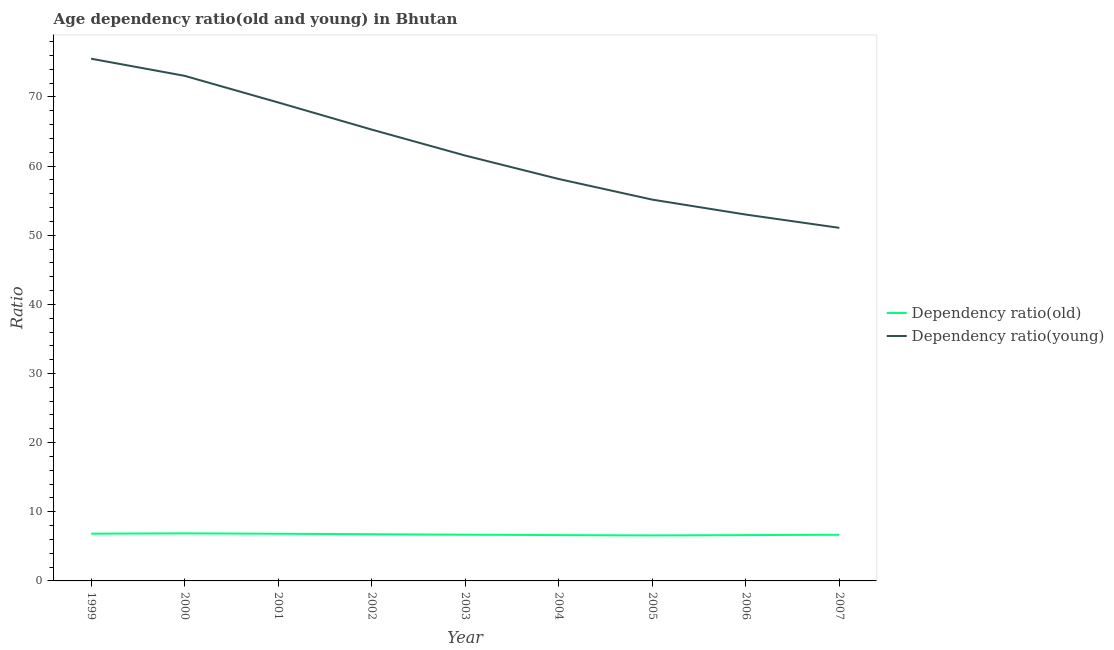How many different coloured lines are there?
Make the answer very short. 2. Does the line corresponding to age dependency ratio(young) intersect with the line corresponding to age dependency ratio(old)?
Make the answer very short. No. What is the age dependency ratio(old) in 2004?
Your answer should be very brief. 6.63. Across all years, what is the maximum age dependency ratio(young)?
Offer a very short reply. 75.53. Across all years, what is the minimum age dependency ratio(old)?
Provide a succinct answer. 6.58. In which year was the age dependency ratio(old) minimum?
Offer a terse response. 2005. What is the total age dependency ratio(young) in the graph?
Your answer should be very brief. 561.95. What is the difference between the age dependency ratio(young) in 2003 and that in 2005?
Your answer should be very brief. 6.37. What is the difference between the age dependency ratio(young) in 1999 and the age dependency ratio(old) in 2001?
Give a very brief answer. 68.71. What is the average age dependency ratio(old) per year?
Provide a succinct answer. 6.72. In the year 1999, what is the difference between the age dependency ratio(old) and age dependency ratio(young)?
Offer a terse response. -68.7. What is the ratio of the age dependency ratio(old) in 2001 to that in 2005?
Provide a short and direct response. 1.04. What is the difference between the highest and the second highest age dependency ratio(old)?
Ensure brevity in your answer.  0.05. What is the difference between the highest and the lowest age dependency ratio(old)?
Your answer should be compact. 0.3. How many legend labels are there?
Your answer should be compact. 2. What is the title of the graph?
Your answer should be compact. Age dependency ratio(old and young) in Bhutan. What is the label or title of the Y-axis?
Your answer should be compact. Ratio. What is the Ratio in Dependency ratio(old) in 1999?
Offer a terse response. 6.83. What is the Ratio in Dependency ratio(young) in 1999?
Keep it short and to the point. 75.53. What is the Ratio in Dependency ratio(old) in 2000?
Offer a terse response. 6.88. What is the Ratio in Dependency ratio(young) in 2000?
Ensure brevity in your answer.  73.06. What is the Ratio in Dependency ratio(old) in 2001?
Offer a very short reply. 6.82. What is the Ratio in Dependency ratio(young) in 2001?
Your response must be concise. 69.21. What is the Ratio of Dependency ratio(old) in 2002?
Your answer should be very brief. 6.75. What is the Ratio of Dependency ratio(young) in 2002?
Your answer should be compact. 65.28. What is the Ratio of Dependency ratio(old) in 2003?
Your answer should be compact. 6.69. What is the Ratio of Dependency ratio(young) in 2003?
Your answer should be compact. 61.53. What is the Ratio of Dependency ratio(old) in 2004?
Offer a very short reply. 6.63. What is the Ratio in Dependency ratio(young) in 2004?
Provide a short and direct response. 58.14. What is the Ratio of Dependency ratio(old) in 2005?
Your answer should be compact. 6.58. What is the Ratio in Dependency ratio(young) in 2005?
Provide a short and direct response. 55.15. What is the Ratio of Dependency ratio(old) in 2006?
Your response must be concise. 6.63. What is the Ratio in Dependency ratio(young) in 2006?
Offer a very short reply. 52.99. What is the Ratio of Dependency ratio(old) in 2007?
Your answer should be compact. 6.68. What is the Ratio of Dependency ratio(young) in 2007?
Make the answer very short. 51.07. Across all years, what is the maximum Ratio in Dependency ratio(old)?
Offer a very short reply. 6.88. Across all years, what is the maximum Ratio in Dependency ratio(young)?
Provide a short and direct response. 75.53. Across all years, what is the minimum Ratio of Dependency ratio(old)?
Offer a very short reply. 6.58. Across all years, what is the minimum Ratio in Dependency ratio(young)?
Keep it short and to the point. 51.07. What is the total Ratio of Dependency ratio(old) in the graph?
Your answer should be compact. 60.49. What is the total Ratio of Dependency ratio(young) in the graph?
Your answer should be very brief. 561.95. What is the difference between the Ratio of Dependency ratio(old) in 1999 and that in 2000?
Offer a terse response. -0.05. What is the difference between the Ratio in Dependency ratio(young) in 1999 and that in 2000?
Provide a succinct answer. 2.48. What is the difference between the Ratio of Dependency ratio(old) in 1999 and that in 2001?
Offer a very short reply. 0.01. What is the difference between the Ratio in Dependency ratio(young) in 1999 and that in 2001?
Make the answer very short. 6.33. What is the difference between the Ratio of Dependency ratio(old) in 1999 and that in 2002?
Give a very brief answer. 0.08. What is the difference between the Ratio of Dependency ratio(young) in 1999 and that in 2002?
Offer a very short reply. 10.25. What is the difference between the Ratio of Dependency ratio(old) in 1999 and that in 2003?
Keep it short and to the point. 0.15. What is the difference between the Ratio in Dependency ratio(young) in 1999 and that in 2003?
Keep it short and to the point. 14.01. What is the difference between the Ratio of Dependency ratio(old) in 1999 and that in 2004?
Your answer should be compact. 0.2. What is the difference between the Ratio in Dependency ratio(young) in 1999 and that in 2004?
Your answer should be compact. 17.4. What is the difference between the Ratio of Dependency ratio(old) in 1999 and that in 2005?
Provide a short and direct response. 0.25. What is the difference between the Ratio in Dependency ratio(young) in 1999 and that in 2005?
Offer a terse response. 20.38. What is the difference between the Ratio in Dependency ratio(old) in 1999 and that in 2006?
Keep it short and to the point. 0.2. What is the difference between the Ratio in Dependency ratio(young) in 1999 and that in 2006?
Keep it short and to the point. 22.54. What is the difference between the Ratio in Dependency ratio(old) in 1999 and that in 2007?
Keep it short and to the point. 0.16. What is the difference between the Ratio of Dependency ratio(young) in 1999 and that in 2007?
Your answer should be very brief. 24.46. What is the difference between the Ratio of Dependency ratio(old) in 2000 and that in 2001?
Your answer should be very brief. 0.06. What is the difference between the Ratio in Dependency ratio(young) in 2000 and that in 2001?
Offer a very short reply. 3.85. What is the difference between the Ratio in Dependency ratio(old) in 2000 and that in 2002?
Your answer should be very brief. 0.13. What is the difference between the Ratio of Dependency ratio(young) in 2000 and that in 2002?
Offer a terse response. 7.78. What is the difference between the Ratio in Dependency ratio(old) in 2000 and that in 2003?
Provide a succinct answer. 0.19. What is the difference between the Ratio in Dependency ratio(young) in 2000 and that in 2003?
Make the answer very short. 11.53. What is the difference between the Ratio of Dependency ratio(old) in 2000 and that in 2004?
Provide a succinct answer. 0.25. What is the difference between the Ratio in Dependency ratio(young) in 2000 and that in 2004?
Give a very brief answer. 14.92. What is the difference between the Ratio of Dependency ratio(old) in 2000 and that in 2005?
Provide a short and direct response. 0.3. What is the difference between the Ratio in Dependency ratio(young) in 2000 and that in 2005?
Give a very brief answer. 17.91. What is the difference between the Ratio of Dependency ratio(old) in 2000 and that in 2006?
Provide a succinct answer. 0.25. What is the difference between the Ratio in Dependency ratio(young) in 2000 and that in 2006?
Provide a short and direct response. 20.07. What is the difference between the Ratio in Dependency ratio(old) in 2000 and that in 2007?
Your answer should be very brief. 0.2. What is the difference between the Ratio of Dependency ratio(young) in 2000 and that in 2007?
Ensure brevity in your answer.  21.99. What is the difference between the Ratio in Dependency ratio(old) in 2001 and that in 2002?
Your answer should be very brief. 0.07. What is the difference between the Ratio in Dependency ratio(young) in 2001 and that in 2002?
Ensure brevity in your answer.  3.93. What is the difference between the Ratio of Dependency ratio(old) in 2001 and that in 2003?
Keep it short and to the point. 0.14. What is the difference between the Ratio in Dependency ratio(young) in 2001 and that in 2003?
Your response must be concise. 7.68. What is the difference between the Ratio in Dependency ratio(old) in 2001 and that in 2004?
Offer a very short reply. 0.19. What is the difference between the Ratio of Dependency ratio(young) in 2001 and that in 2004?
Your answer should be very brief. 11.07. What is the difference between the Ratio of Dependency ratio(old) in 2001 and that in 2005?
Give a very brief answer. 0.24. What is the difference between the Ratio of Dependency ratio(young) in 2001 and that in 2005?
Your response must be concise. 14.06. What is the difference between the Ratio in Dependency ratio(old) in 2001 and that in 2006?
Keep it short and to the point. 0.19. What is the difference between the Ratio of Dependency ratio(young) in 2001 and that in 2006?
Offer a very short reply. 16.22. What is the difference between the Ratio of Dependency ratio(old) in 2001 and that in 2007?
Give a very brief answer. 0.15. What is the difference between the Ratio of Dependency ratio(young) in 2001 and that in 2007?
Your answer should be compact. 18.14. What is the difference between the Ratio in Dependency ratio(old) in 2002 and that in 2003?
Keep it short and to the point. 0.07. What is the difference between the Ratio of Dependency ratio(young) in 2002 and that in 2003?
Keep it short and to the point. 3.76. What is the difference between the Ratio of Dependency ratio(old) in 2002 and that in 2004?
Ensure brevity in your answer.  0.13. What is the difference between the Ratio in Dependency ratio(young) in 2002 and that in 2004?
Your response must be concise. 7.15. What is the difference between the Ratio in Dependency ratio(old) in 2002 and that in 2005?
Make the answer very short. 0.17. What is the difference between the Ratio in Dependency ratio(young) in 2002 and that in 2005?
Your answer should be compact. 10.13. What is the difference between the Ratio in Dependency ratio(old) in 2002 and that in 2006?
Offer a terse response. 0.12. What is the difference between the Ratio in Dependency ratio(young) in 2002 and that in 2006?
Offer a terse response. 12.29. What is the difference between the Ratio in Dependency ratio(old) in 2002 and that in 2007?
Offer a very short reply. 0.08. What is the difference between the Ratio of Dependency ratio(young) in 2002 and that in 2007?
Provide a short and direct response. 14.21. What is the difference between the Ratio in Dependency ratio(old) in 2003 and that in 2004?
Give a very brief answer. 0.06. What is the difference between the Ratio of Dependency ratio(young) in 2003 and that in 2004?
Your answer should be compact. 3.39. What is the difference between the Ratio of Dependency ratio(old) in 2003 and that in 2005?
Offer a very short reply. 0.1. What is the difference between the Ratio in Dependency ratio(young) in 2003 and that in 2005?
Offer a terse response. 6.37. What is the difference between the Ratio in Dependency ratio(old) in 2003 and that in 2006?
Your answer should be very brief. 0.06. What is the difference between the Ratio in Dependency ratio(young) in 2003 and that in 2006?
Provide a succinct answer. 8.53. What is the difference between the Ratio in Dependency ratio(old) in 2003 and that in 2007?
Offer a terse response. 0.01. What is the difference between the Ratio of Dependency ratio(young) in 2003 and that in 2007?
Provide a short and direct response. 10.46. What is the difference between the Ratio in Dependency ratio(old) in 2004 and that in 2005?
Your answer should be very brief. 0.05. What is the difference between the Ratio of Dependency ratio(young) in 2004 and that in 2005?
Offer a terse response. 2.98. What is the difference between the Ratio of Dependency ratio(old) in 2004 and that in 2006?
Ensure brevity in your answer.  -0. What is the difference between the Ratio of Dependency ratio(young) in 2004 and that in 2006?
Provide a succinct answer. 5.14. What is the difference between the Ratio in Dependency ratio(old) in 2004 and that in 2007?
Offer a very short reply. -0.05. What is the difference between the Ratio in Dependency ratio(young) in 2004 and that in 2007?
Ensure brevity in your answer.  7.07. What is the difference between the Ratio in Dependency ratio(old) in 2005 and that in 2006?
Your response must be concise. -0.05. What is the difference between the Ratio in Dependency ratio(young) in 2005 and that in 2006?
Provide a short and direct response. 2.16. What is the difference between the Ratio of Dependency ratio(old) in 2005 and that in 2007?
Your answer should be compact. -0.09. What is the difference between the Ratio of Dependency ratio(young) in 2005 and that in 2007?
Your answer should be very brief. 4.08. What is the difference between the Ratio of Dependency ratio(old) in 2006 and that in 2007?
Offer a very short reply. -0.05. What is the difference between the Ratio of Dependency ratio(young) in 2006 and that in 2007?
Your response must be concise. 1.92. What is the difference between the Ratio in Dependency ratio(old) in 1999 and the Ratio in Dependency ratio(young) in 2000?
Your answer should be compact. -66.22. What is the difference between the Ratio in Dependency ratio(old) in 1999 and the Ratio in Dependency ratio(young) in 2001?
Make the answer very short. -62.37. What is the difference between the Ratio of Dependency ratio(old) in 1999 and the Ratio of Dependency ratio(young) in 2002?
Your answer should be very brief. -58.45. What is the difference between the Ratio of Dependency ratio(old) in 1999 and the Ratio of Dependency ratio(young) in 2003?
Provide a succinct answer. -54.69. What is the difference between the Ratio in Dependency ratio(old) in 1999 and the Ratio in Dependency ratio(young) in 2004?
Keep it short and to the point. -51.3. What is the difference between the Ratio in Dependency ratio(old) in 1999 and the Ratio in Dependency ratio(young) in 2005?
Offer a terse response. -48.32. What is the difference between the Ratio in Dependency ratio(old) in 1999 and the Ratio in Dependency ratio(young) in 2006?
Your response must be concise. -46.16. What is the difference between the Ratio in Dependency ratio(old) in 1999 and the Ratio in Dependency ratio(young) in 2007?
Make the answer very short. -44.24. What is the difference between the Ratio in Dependency ratio(old) in 2000 and the Ratio in Dependency ratio(young) in 2001?
Your answer should be very brief. -62.33. What is the difference between the Ratio of Dependency ratio(old) in 2000 and the Ratio of Dependency ratio(young) in 2002?
Give a very brief answer. -58.4. What is the difference between the Ratio in Dependency ratio(old) in 2000 and the Ratio in Dependency ratio(young) in 2003?
Offer a terse response. -54.64. What is the difference between the Ratio of Dependency ratio(old) in 2000 and the Ratio of Dependency ratio(young) in 2004?
Ensure brevity in your answer.  -51.26. What is the difference between the Ratio in Dependency ratio(old) in 2000 and the Ratio in Dependency ratio(young) in 2005?
Your answer should be very brief. -48.27. What is the difference between the Ratio of Dependency ratio(old) in 2000 and the Ratio of Dependency ratio(young) in 2006?
Your answer should be compact. -46.11. What is the difference between the Ratio of Dependency ratio(old) in 2000 and the Ratio of Dependency ratio(young) in 2007?
Provide a short and direct response. -44.19. What is the difference between the Ratio in Dependency ratio(old) in 2001 and the Ratio in Dependency ratio(young) in 2002?
Give a very brief answer. -58.46. What is the difference between the Ratio of Dependency ratio(old) in 2001 and the Ratio of Dependency ratio(young) in 2003?
Provide a short and direct response. -54.7. What is the difference between the Ratio in Dependency ratio(old) in 2001 and the Ratio in Dependency ratio(young) in 2004?
Give a very brief answer. -51.31. What is the difference between the Ratio of Dependency ratio(old) in 2001 and the Ratio of Dependency ratio(young) in 2005?
Ensure brevity in your answer.  -48.33. What is the difference between the Ratio in Dependency ratio(old) in 2001 and the Ratio in Dependency ratio(young) in 2006?
Offer a very short reply. -46.17. What is the difference between the Ratio of Dependency ratio(old) in 2001 and the Ratio of Dependency ratio(young) in 2007?
Offer a very short reply. -44.25. What is the difference between the Ratio of Dependency ratio(old) in 2002 and the Ratio of Dependency ratio(young) in 2003?
Give a very brief answer. -54.77. What is the difference between the Ratio in Dependency ratio(old) in 2002 and the Ratio in Dependency ratio(young) in 2004?
Your response must be concise. -51.38. What is the difference between the Ratio of Dependency ratio(old) in 2002 and the Ratio of Dependency ratio(young) in 2005?
Your response must be concise. -48.4. What is the difference between the Ratio in Dependency ratio(old) in 2002 and the Ratio in Dependency ratio(young) in 2006?
Offer a very short reply. -46.24. What is the difference between the Ratio in Dependency ratio(old) in 2002 and the Ratio in Dependency ratio(young) in 2007?
Give a very brief answer. -44.32. What is the difference between the Ratio in Dependency ratio(old) in 2003 and the Ratio in Dependency ratio(young) in 2004?
Ensure brevity in your answer.  -51.45. What is the difference between the Ratio in Dependency ratio(old) in 2003 and the Ratio in Dependency ratio(young) in 2005?
Offer a terse response. -48.46. What is the difference between the Ratio in Dependency ratio(old) in 2003 and the Ratio in Dependency ratio(young) in 2006?
Offer a very short reply. -46.3. What is the difference between the Ratio in Dependency ratio(old) in 2003 and the Ratio in Dependency ratio(young) in 2007?
Provide a short and direct response. -44.38. What is the difference between the Ratio in Dependency ratio(old) in 2004 and the Ratio in Dependency ratio(young) in 2005?
Offer a very short reply. -48.52. What is the difference between the Ratio of Dependency ratio(old) in 2004 and the Ratio of Dependency ratio(young) in 2006?
Your response must be concise. -46.36. What is the difference between the Ratio of Dependency ratio(old) in 2004 and the Ratio of Dependency ratio(young) in 2007?
Give a very brief answer. -44.44. What is the difference between the Ratio in Dependency ratio(old) in 2005 and the Ratio in Dependency ratio(young) in 2006?
Offer a very short reply. -46.41. What is the difference between the Ratio of Dependency ratio(old) in 2005 and the Ratio of Dependency ratio(young) in 2007?
Keep it short and to the point. -44.49. What is the difference between the Ratio in Dependency ratio(old) in 2006 and the Ratio in Dependency ratio(young) in 2007?
Your answer should be compact. -44.44. What is the average Ratio of Dependency ratio(old) per year?
Make the answer very short. 6.72. What is the average Ratio in Dependency ratio(young) per year?
Provide a succinct answer. 62.44. In the year 1999, what is the difference between the Ratio in Dependency ratio(old) and Ratio in Dependency ratio(young)?
Offer a terse response. -68.7. In the year 2000, what is the difference between the Ratio of Dependency ratio(old) and Ratio of Dependency ratio(young)?
Your answer should be compact. -66.18. In the year 2001, what is the difference between the Ratio in Dependency ratio(old) and Ratio in Dependency ratio(young)?
Your answer should be compact. -62.38. In the year 2002, what is the difference between the Ratio of Dependency ratio(old) and Ratio of Dependency ratio(young)?
Your answer should be very brief. -58.53. In the year 2003, what is the difference between the Ratio of Dependency ratio(old) and Ratio of Dependency ratio(young)?
Provide a succinct answer. -54.84. In the year 2004, what is the difference between the Ratio in Dependency ratio(old) and Ratio in Dependency ratio(young)?
Ensure brevity in your answer.  -51.51. In the year 2005, what is the difference between the Ratio of Dependency ratio(old) and Ratio of Dependency ratio(young)?
Give a very brief answer. -48.57. In the year 2006, what is the difference between the Ratio of Dependency ratio(old) and Ratio of Dependency ratio(young)?
Give a very brief answer. -46.36. In the year 2007, what is the difference between the Ratio in Dependency ratio(old) and Ratio in Dependency ratio(young)?
Your answer should be compact. -44.39. What is the ratio of the Ratio of Dependency ratio(old) in 1999 to that in 2000?
Your answer should be compact. 0.99. What is the ratio of the Ratio of Dependency ratio(young) in 1999 to that in 2000?
Offer a very short reply. 1.03. What is the ratio of the Ratio in Dependency ratio(young) in 1999 to that in 2001?
Your answer should be very brief. 1.09. What is the ratio of the Ratio in Dependency ratio(old) in 1999 to that in 2002?
Your response must be concise. 1.01. What is the ratio of the Ratio in Dependency ratio(young) in 1999 to that in 2002?
Provide a short and direct response. 1.16. What is the ratio of the Ratio in Dependency ratio(old) in 1999 to that in 2003?
Keep it short and to the point. 1.02. What is the ratio of the Ratio in Dependency ratio(young) in 1999 to that in 2003?
Provide a succinct answer. 1.23. What is the ratio of the Ratio of Dependency ratio(old) in 1999 to that in 2004?
Your answer should be compact. 1.03. What is the ratio of the Ratio of Dependency ratio(young) in 1999 to that in 2004?
Offer a terse response. 1.3. What is the ratio of the Ratio in Dependency ratio(old) in 1999 to that in 2005?
Offer a terse response. 1.04. What is the ratio of the Ratio in Dependency ratio(young) in 1999 to that in 2005?
Provide a short and direct response. 1.37. What is the ratio of the Ratio in Dependency ratio(old) in 1999 to that in 2006?
Ensure brevity in your answer.  1.03. What is the ratio of the Ratio of Dependency ratio(young) in 1999 to that in 2006?
Make the answer very short. 1.43. What is the ratio of the Ratio of Dependency ratio(old) in 1999 to that in 2007?
Your response must be concise. 1.02. What is the ratio of the Ratio of Dependency ratio(young) in 1999 to that in 2007?
Your response must be concise. 1.48. What is the ratio of the Ratio in Dependency ratio(old) in 2000 to that in 2001?
Make the answer very short. 1.01. What is the ratio of the Ratio of Dependency ratio(young) in 2000 to that in 2001?
Make the answer very short. 1.06. What is the ratio of the Ratio of Dependency ratio(old) in 2000 to that in 2002?
Offer a terse response. 1.02. What is the ratio of the Ratio in Dependency ratio(young) in 2000 to that in 2002?
Your answer should be compact. 1.12. What is the ratio of the Ratio of Dependency ratio(young) in 2000 to that in 2003?
Your answer should be very brief. 1.19. What is the ratio of the Ratio in Dependency ratio(old) in 2000 to that in 2004?
Provide a short and direct response. 1.04. What is the ratio of the Ratio in Dependency ratio(young) in 2000 to that in 2004?
Keep it short and to the point. 1.26. What is the ratio of the Ratio in Dependency ratio(old) in 2000 to that in 2005?
Offer a terse response. 1.05. What is the ratio of the Ratio in Dependency ratio(young) in 2000 to that in 2005?
Make the answer very short. 1.32. What is the ratio of the Ratio of Dependency ratio(old) in 2000 to that in 2006?
Offer a very short reply. 1.04. What is the ratio of the Ratio in Dependency ratio(young) in 2000 to that in 2006?
Your answer should be compact. 1.38. What is the ratio of the Ratio of Dependency ratio(old) in 2000 to that in 2007?
Offer a very short reply. 1.03. What is the ratio of the Ratio of Dependency ratio(young) in 2000 to that in 2007?
Offer a terse response. 1.43. What is the ratio of the Ratio in Dependency ratio(old) in 2001 to that in 2002?
Ensure brevity in your answer.  1.01. What is the ratio of the Ratio in Dependency ratio(young) in 2001 to that in 2002?
Offer a very short reply. 1.06. What is the ratio of the Ratio of Dependency ratio(old) in 2001 to that in 2003?
Offer a very short reply. 1.02. What is the ratio of the Ratio in Dependency ratio(young) in 2001 to that in 2003?
Ensure brevity in your answer.  1.12. What is the ratio of the Ratio in Dependency ratio(old) in 2001 to that in 2004?
Give a very brief answer. 1.03. What is the ratio of the Ratio of Dependency ratio(young) in 2001 to that in 2004?
Your response must be concise. 1.19. What is the ratio of the Ratio of Dependency ratio(old) in 2001 to that in 2005?
Your answer should be compact. 1.04. What is the ratio of the Ratio in Dependency ratio(young) in 2001 to that in 2005?
Your answer should be compact. 1.25. What is the ratio of the Ratio in Dependency ratio(old) in 2001 to that in 2006?
Offer a terse response. 1.03. What is the ratio of the Ratio of Dependency ratio(young) in 2001 to that in 2006?
Your response must be concise. 1.31. What is the ratio of the Ratio of Dependency ratio(old) in 2001 to that in 2007?
Offer a very short reply. 1.02. What is the ratio of the Ratio of Dependency ratio(young) in 2001 to that in 2007?
Keep it short and to the point. 1.36. What is the ratio of the Ratio in Dependency ratio(old) in 2002 to that in 2003?
Offer a very short reply. 1.01. What is the ratio of the Ratio in Dependency ratio(young) in 2002 to that in 2003?
Offer a terse response. 1.06. What is the ratio of the Ratio of Dependency ratio(old) in 2002 to that in 2004?
Give a very brief answer. 1.02. What is the ratio of the Ratio in Dependency ratio(young) in 2002 to that in 2004?
Offer a very short reply. 1.12. What is the ratio of the Ratio of Dependency ratio(old) in 2002 to that in 2005?
Provide a short and direct response. 1.03. What is the ratio of the Ratio in Dependency ratio(young) in 2002 to that in 2005?
Give a very brief answer. 1.18. What is the ratio of the Ratio in Dependency ratio(old) in 2002 to that in 2006?
Make the answer very short. 1.02. What is the ratio of the Ratio in Dependency ratio(young) in 2002 to that in 2006?
Offer a very short reply. 1.23. What is the ratio of the Ratio of Dependency ratio(old) in 2002 to that in 2007?
Ensure brevity in your answer.  1.01. What is the ratio of the Ratio in Dependency ratio(young) in 2002 to that in 2007?
Your response must be concise. 1.28. What is the ratio of the Ratio of Dependency ratio(old) in 2003 to that in 2004?
Your response must be concise. 1.01. What is the ratio of the Ratio in Dependency ratio(young) in 2003 to that in 2004?
Your response must be concise. 1.06. What is the ratio of the Ratio of Dependency ratio(old) in 2003 to that in 2005?
Give a very brief answer. 1.02. What is the ratio of the Ratio of Dependency ratio(young) in 2003 to that in 2005?
Your answer should be compact. 1.12. What is the ratio of the Ratio in Dependency ratio(old) in 2003 to that in 2006?
Your answer should be compact. 1.01. What is the ratio of the Ratio of Dependency ratio(young) in 2003 to that in 2006?
Your response must be concise. 1.16. What is the ratio of the Ratio in Dependency ratio(old) in 2003 to that in 2007?
Ensure brevity in your answer.  1. What is the ratio of the Ratio of Dependency ratio(young) in 2003 to that in 2007?
Keep it short and to the point. 1.2. What is the ratio of the Ratio in Dependency ratio(old) in 2004 to that in 2005?
Provide a succinct answer. 1.01. What is the ratio of the Ratio in Dependency ratio(young) in 2004 to that in 2005?
Offer a very short reply. 1.05. What is the ratio of the Ratio in Dependency ratio(old) in 2004 to that in 2006?
Provide a short and direct response. 1. What is the ratio of the Ratio in Dependency ratio(young) in 2004 to that in 2006?
Offer a very short reply. 1.1. What is the ratio of the Ratio in Dependency ratio(old) in 2004 to that in 2007?
Offer a very short reply. 0.99. What is the ratio of the Ratio of Dependency ratio(young) in 2004 to that in 2007?
Ensure brevity in your answer.  1.14. What is the ratio of the Ratio of Dependency ratio(old) in 2005 to that in 2006?
Your response must be concise. 0.99. What is the ratio of the Ratio of Dependency ratio(young) in 2005 to that in 2006?
Ensure brevity in your answer.  1.04. What is the ratio of the Ratio of Dependency ratio(old) in 2005 to that in 2007?
Your response must be concise. 0.99. What is the ratio of the Ratio of Dependency ratio(young) in 2005 to that in 2007?
Provide a succinct answer. 1.08. What is the ratio of the Ratio in Dependency ratio(young) in 2006 to that in 2007?
Offer a very short reply. 1.04. What is the difference between the highest and the second highest Ratio in Dependency ratio(old)?
Your response must be concise. 0.05. What is the difference between the highest and the second highest Ratio of Dependency ratio(young)?
Offer a terse response. 2.48. What is the difference between the highest and the lowest Ratio in Dependency ratio(old)?
Offer a terse response. 0.3. What is the difference between the highest and the lowest Ratio in Dependency ratio(young)?
Give a very brief answer. 24.46. 